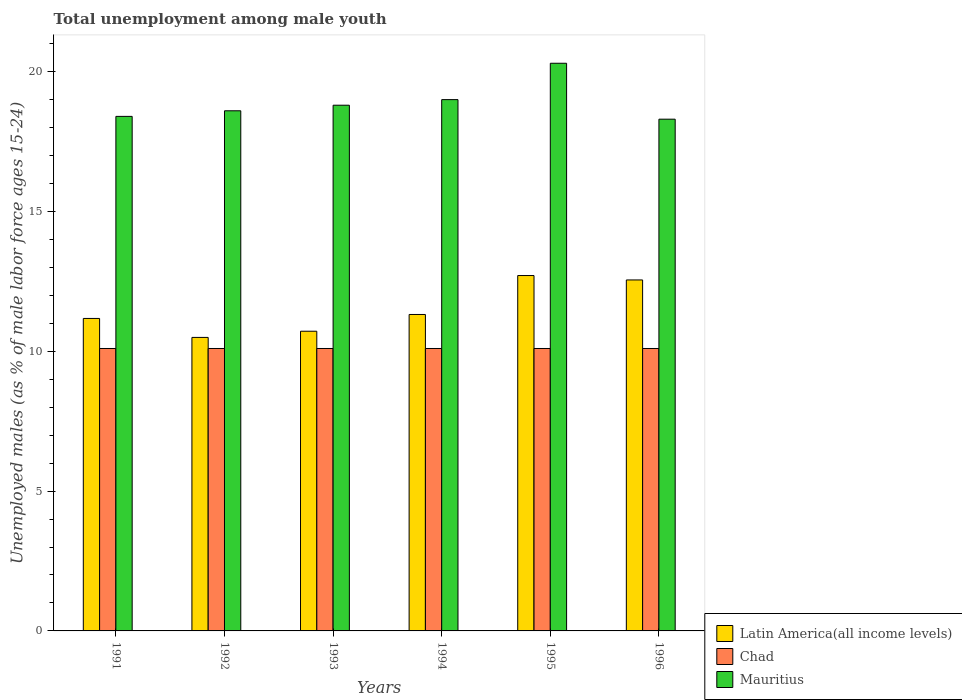Are the number of bars on each tick of the X-axis equal?
Offer a very short reply. Yes. How many bars are there on the 1st tick from the right?
Provide a succinct answer. 3. What is the label of the 5th group of bars from the left?
Ensure brevity in your answer.  1995. In how many cases, is the number of bars for a given year not equal to the number of legend labels?
Offer a terse response. 0. What is the percentage of unemployed males in in Chad in 1993?
Your answer should be very brief. 10.1. Across all years, what is the maximum percentage of unemployed males in in Latin America(all income levels)?
Keep it short and to the point. 12.71. Across all years, what is the minimum percentage of unemployed males in in Mauritius?
Your response must be concise. 18.3. In which year was the percentage of unemployed males in in Chad minimum?
Your answer should be very brief. 1991. What is the total percentage of unemployed males in in Latin America(all income levels) in the graph?
Offer a very short reply. 68.96. What is the difference between the percentage of unemployed males in in Mauritius in 1993 and that in 1995?
Ensure brevity in your answer.  -1.5. What is the difference between the percentage of unemployed males in in Mauritius in 1994 and the percentage of unemployed males in in Chad in 1995?
Provide a succinct answer. 8.9. What is the average percentage of unemployed males in in Mauritius per year?
Make the answer very short. 18.9. In the year 1995, what is the difference between the percentage of unemployed males in in Chad and percentage of unemployed males in in Latin America(all income levels)?
Offer a very short reply. -2.61. In how many years, is the percentage of unemployed males in in Mauritius greater than 18 %?
Your answer should be compact. 6. What is the ratio of the percentage of unemployed males in in Latin America(all income levels) in 1993 to that in 1994?
Keep it short and to the point. 0.95. Is the percentage of unemployed males in in Mauritius in 1993 less than that in 1995?
Keep it short and to the point. Yes. What is the difference between the highest and the second highest percentage of unemployed males in in Latin America(all income levels)?
Offer a terse response. 0.16. What is the difference between the highest and the lowest percentage of unemployed males in in Latin America(all income levels)?
Make the answer very short. 2.21. What does the 2nd bar from the left in 1992 represents?
Make the answer very short. Chad. What does the 1st bar from the right in 1994 represents?
Your answer should be compact. Mauritius. Is it the case that in every year, the sum of the percentage of unemployed males in in Latin America(all income levels) and percentage of unemployed males in in Mauritius is greater than the percentage of unemployed males in in Chad?
Your response must be concise. Yes. Are all the bars in the graph horizontal?
Keep it short and to the point. No. How many years are there in the graph?
Make the answer very short. 6. What is the difference between two consecutive major ticks on the Y-axis?
Make the answer very short. 5. Does the graph contain any zero values?
Your response must be concise. No. Does the graph contain grids?
Provide a short and direct response. No. Where does the legend appear in the graph?
Keep it short and to the point. Bottom right. What is the title of the graph?
Your response must be concise. Total unemployment among male youth. What is the label or title of the Y-axis?
Keep it short and to the point. Unemployed males (as % of male labor force ages 15-24). What is the Unemployed males (as % of male labor force ages 15-24) of Latin America(all income levels) in 1991?
Offer a terse response. 11.17. What is the Unemployed males (as % of male labor force ages 15-24) of Chad in 1991?
Keep it short and to the point. 10.1. What is the Unemployed males (as % of male labor force ages 15-24) of Mauritius in 1991?
Offer a very short reply. 18.4. What is the Unemployed males (as % of male labor force ages 15-24) in Latin America(all income levels) in 1992?
Provide a succinct answer. 10.5. What is the Unemployed males (as % of male labor force ages 15-24) of Chad in 1992?
Provide a short and direct response. 10.1. What is the Unemployed males (as % of male labor force ages 15-24) in Mauritius in 1992?
Provide a short and direct response. 18.6. What is the Unemployed males (as % of male labor force ages 15-24) in Latin America(all income levels) in 1993?
Your answer should be very brief. 10.72. What is the Unemployed males (as % of male labor force ages 15-24) in Chad in 1993?
Provide a succinct answer. 10.1. What is the Unemployed males (as % of male labor force ages 15-24) of Mauritius in 1993?
Offer a terse response. 18.8. What is the Unemployed males (as % of male labor force ages 15-24) in Latin America(all income levels) in 1994?
Ensure brevity in your answer.  11.32. What is the Unemployed males (as % of male labor force ages 15-24) in Chad in 1994?
Offer a terse response. 10.1. What is the Unemployed males (as % of male labor force ages 15-24) of Mauritius in 1994?
Ensure brevity in your answer.  19. What is the Unemployed males (as % of male labor force ages 15-24) in Latin America(all income levels) in 1995?
Ensure brevity in your answer.  12.71. What is the Unemployed males (as % of male labor force ages 15-24) in Chad in 1995?
Give a very brief answer. 10.1. What is the Unemployed males (as % of male labor force ages 15-24) of Mauritius in 1995?
Provide a short and direct response. 20.3. What is the Unemployed males (as % of male labor force ages 15-24) in Latin America(all income levels) in 1996?
Give a very brief answer. 12.55. What is the Unemployed males (as % of male labor force ages 15-24) in Chad in 1996?
Make the answer very short. 10.1. What is the Unemployed males (as % of male labor force ages 15-24) of Mauritius in 1996?
Provide a succinct answer. 18.3. Across all years, what is the maximum Unemployed males (as % of male labor force ages 15-24) in Latin America(all income levels)?
Offer a terse response. 12.71. Across all years, what is the maximum Unemployed males (as % of male labor force ages 15-24) in Chad?
Keep it short and to the point. 10.1. Across all years, what is the maximum Unemployed males (as % of male labor force ages 15-24) of Mauritius?
Make the answer very short. 20.3. Across all years, what is the minimum Unemployed males (as % of male labor force ages 15-24) in Latin America(all income levels)?
Your response must be concise. 10.5. Across all years, what is the minimum Unemployed males (as % of male labor force ages 15-24) in Chad?
Your answer should be compact. 10.1. Across all years, what is the minimum Unemployed males (as % of male labor force ages 15-24) of Mauritius?
Give a very brief answer. 18.3. What is the total Unemployed males (as % of male labor force ages 15-24) of Latin America(all income levels) in the graph?
Provide a short and direct response. 68.96. What is the total Unemployed males (as % of male labor force ages 15-24) in Chad in the graph?
Ensure brevity in your answer.  60.6. What is the total Unemployed males (as % of male labor force ages 15-24) in Mauritius in the graph?
Provide a succinct answer. 113.4. What is the difference between the Unemployed males (as % of male labor force ages 15-24) in Latin America(all income levels) in 1991 and that in 1992?
Make the answer very short. 0.68. What is the difference between the Unemployed males (as % of male labor force ages 15-24) of Latin America(all income levels) in 1991 and that in 1993?
Offer a very short reply. 0.46. What is the difference between the Unemployed males (as % of male labor force ages 15-24) in Mauritius in 1991 and that in 1993?
Your answer should be very brief. -0.4. What is the difference between the Unemployed males (as % of male labor force ages 15-24) of Latin America(all income levels) in 1991 and that in 1994?
Your response must be concise. -0.14. What is the difference between the Unemployed males (as % of male labor force ages 15-24) of Mauritius in 1991 and that in 1994?
Your answer should be very brief. -0.6. What is the difference between the Unemployed males (as % of male labor force ages 15-24) in Latin America(all income levels) in 1991 and that in 1995?
Ensure brevity in your answer.  -1.53. What is the difference between the Unemployed males (as % of male labor force ages 15-24) of Chad in 1991 and that in 1995?
Offer a very short reply. 0. What is the difference between the Unemployed males (as % of male labor force ages 15-24) of Latin America(all income levels) in 1991 and that in 1996?
Ensure brevity in your answer.  -1.38. What is the difference between the Unemployed males (as % of male labor force ages 15-24) of Chad in 1991 and that in 1996?
Your answer should be very brief. 0. What is the difference between the Unemployed males (as % of male labor force ages 15-24) of Mauritius in 1991 and that in 1996?
Your response must be concise. 0.1. What is the difference between the Unemployed males (as % of male labor force ages 15-24) of Latin America(all income levels) in 1992 and that in 1993?
Your answer should be very brief. -0.22. What is the difference between the Unemployed males (as % of male labor force ages 15-24) in Mauritius in 1992 and that in 1993?
Your answer should be very brief. -0.2. What is the difference between the Unemployed males (as % of male labor force ages 15-24) of Latin America(all income levels) in 1992 and that in 1994?
Provide a succinct answer. -0.82. What is the difference between the Unemployed males (as % of male labor force ages 15-24) in Latin America(all income levels) in 1992 and that in 1995?
Your answer should be very brief. -2.21. What is the difference between the Unemployed males (as % of male labor force ages 15-24) of Chad in 1992 and that in 1995?
Your answer should be very brief. 0. What is the difference between the Unemployed males (as % of male labor force ages 15-24) of Mauritius in 1992 and that in 1995?
Your response must be concise. -1.7. What is the difference between the Unemployed males (as % of male labor force ages 15-24) of Latin America(all income levels) in 1992 and that in 1996?
Provide a short and direct response. -2.06. What is the difference between the Unemployed males (as % of male labor force ages 15-24) of Mauritius in 1992 and that in 1996?
Your response must be concise. 0.3. What is the difference between the Unemployed males (as % of male labor force ages 15-24) of Latin America(all income levels) in 1993 and that in 1994?
Offer a terse response. -0.6. What is the difference between the Unemployed males (as % of male labor force ages 15-24) in Chad in 1993 and that in 1994?
Your answer should be very brief. 0. What is the difference between the Unemployed males (as % of male labor force ages 15-24) of Mauritius in 1993 and that in 1994?
Your response must be concise. -0.2. What is the difference between the Unemployed males (as % of male labor force ages 15-24) of Latin America(all income levels) in 1993 and that in 1995?
Provide a succinct answer. -1.99. What is the difference between the Unemployed males (as % of male labor force ages 15-24) of Latin America(all income levels) in 1993 and that in 1996?
Your answer should be very brief. -1.83. What is the difference between the Unemployed males (as % of male labor force ages 15-24) of Chad in 1993 and that in 1996?
Your response must be concise. 0. What is the difference between the Unemployed males (as % of male labor force ages 15-24) of Mauritius in 1993 and that in 1996?
Provide a succinct answer. 0.5. What is the difference between the Unemployed males (as % of male labor force ages 15-24) of Latin America(all income levels) in 1994 and that in 1995?
Your answer should be compact. -1.39. What is the difference between the Unemployed males (as % of male labor force ages 15-24) of Latin America(all income levels) in 1994 and that in 1996?
Give a very brief answer. -1.24. What is the difference between the Unemployed males (as % of male labor force ages 15-24) in Latin America(all income levels) in 1995 and that in 1996?
Provide a short and direct response. 0.16. What is the difference between the Unemployed males (as % of male labor force ages 15-24) in Latin America(all income levels) in 1991 and the Unemployed males (as % of male labor force ages 15-24) in Chad in 1992?
Provide a short and direct response. 1.07. What is the difference between the Unemployed males (as % of male labor force ages 15-24) in Latin America(all income levels) in 1991 and the Unemployed males (as % of male labor force ages 15-24) in Mauritius in 1992?
Ensure brevity in your answer.  -7.43. What is the difference between the Unemployed males (as % of male labor force ages 15-24) of Chad in 1991 and the Unemployed males (as % of male labor force ages 15-24) of Mauritius in 1992?
Provide a succinct answer. -8.5. What is the difference between the Unemployed males (as % of male labor force ages 15-24) in Latin America(all income levels) in 1991 and the Unemployed males (as % of male labor force ages 15-24) in Chad in 1993?
Provide a short and direct response. 1.07. What is the difference between the Unemployed males (as % of male labor force ages 15-24) of Latin America(all income levels) in 1991 and the Unemployed males (as % of male labor force ages 15-24) of Mauritius in 1993?
Offer a very short reply. -7.63. What is the difference between the Unemployed males (as % of male labor force ages 15-24) of Latin America(all income levels) in 1991 and the Unemployed males (as % of male labor force ages 15-24) of Chad in 1994?
Give a very brief answer. 1.07. What is the difference between the Unemployed males (as % of male labor force ages 15-24) in Latin America(all income levels) in 1991 and the Unemployed males (as % of male labor force ages 15-24) in Mauritius in 1994?
Keep it short and to the point. -7.83. What is the difference between the Unemployed males (as % of male labor force ages 15-24) of Latin America(all income levels) in 1991 and the Unemployed males (as % of male labor force ages 15-24) of Chad in 1995?
Provide a succinct answer. 1.07. What is the difference between the Unemployed males (as % of male labor force ages 15-24) in Latin America(all income levels) in 1991 and the Unemployed males (as % of male labor force ages 15-24) in Mauritius in 1995?
Make the answer very short. -9.13. What is the difference between the Unemployed males (as % of male labor force ages 15-24) of Chad in 1991 and the Unemployed males (as % of male labor force ages 15-24) of Mauritius in 1995?
Offer a terse response. -10.2. What is the difference between the Unemployed males (as % of male labor force ages 15-24) in Latin America(all income levels) in 1991 and the Unemployed males (as % of male labor force ages 15-24) in Chad in 1996?
Offer a terse response. 1.07. What is the difference between the Unemployed males (as % of male labor force ages 15-24) of Latin America(all income levels) in 1991 and the Unemployed males (as % of male labor force ages 15-24) of Mauritius in 1996?
Give a very brief answer. -7.13. What is the difference between the Unemployed males (as % of male labor force ages 15-24) in Chad in 1991 and the Unemployed males (as % of male labor force ages 15-24) in Mauritius in 1996?
Your answer should be compact. -8.2. What is the difference between the Unemployed males (as % of male labor force ages 15-24) of Latin America(all income levels) in 1992 and the Unemployed males (as % of male labor force ages 15-24) of Chad in 1993?
Your answer should be very brief. 0.4. What is the difference between the Unemployed males (as % of male labor force ages 15-24) of Latin America(all income levels) in 1992 and the Unemployed males (as % of male labor force ages 15-24) of Mauritius in 1993?
Your answer should be compact. -8.3. What is the difference between the Unemployed males (as % of male labor force ages 15-24) of Latin America(all income levels) in 1992 and the Unemployed males (as % of male labor force ages 15-24) of Chad in 1994?
Your answer should be compact. 0.4. What is the difference between the Unemployed males (as % of male labor force ages 15-24) in Latin America(all income levels) in 1992 and the Unemployed males (as % of male labor force ages 15-24) in Mauritius in 1994?
Ensure brevity in your answer.  -8.5. What is the difference between the Unemployed males (as % of male labor force ages 15-24) in Latin America(all income levels) in 1992 and the Unemployed males (as % of male labor force ages 15-24) in Chad in 1995?
Offer a terse response. 0.4. What is the difference between the Unemployed males (as % of male labor force ages 15-24) in Latin America(all income levels) in 1992 and the Unemployed males (as % of male labor force ages 15-24) in Mauritius in 1995?
Your response must be concise. -9.8. What is the difference between the Unemployed males (as % of male labor force ages 15-24) in Latin America(all income levels) in 1992 and the Unemployed males (as % of male labor force ages 15-24) in Chad in 1996?
Your answer should be compact. 0.4. What is the difference between the Unemployed males (as % of male labor force ages 15-24) of Latin America(all income levels) in 1992 and the Unemployed males (as % of male labor force ages 15-24) of Mauritius in 1996?
Your response must be concise. -7.8. What is the difference between the Unemployed males (as % of male labor force ages 15-24) of Chad in 1992 and the Unemployed males (as % of male labor force ages 15-24) of Mauritius in 1996?
Keep it short and to the point. -8.2. What is the difference between the Unemployed males (as % of male labor force ages 15-24) in Latin America(all income levels) in 1993 and the Unemployed males (as % of male labor force ages 15-24) in Chad in 1994?
Your answer should be compact. 0.62. What is the difference between the Unemployed males (as % of male labor force ages 15-24) in Latin America(all income levels) in 1993 and the Unemployed males (as % of male labor force ages 15-24) in Mauritius in 1994?
Make the answer very short. -8.28. What is the difference between the Unemployed males (as % of male labor force ages 15-24) in Chad in 1993 and the Unemployed males (as % of male labor force ages 15-24) in Mauritius in 1994?
Ensure brevity in your answer.  -8.9. What is the difference between the Unemployed males (as % of male labor force ages 15-24) in Latin America(all income levels) in 1993 and the Unemployed males (as % of male labor force ages 15-24) in Chad in 1995?
Your answer should be very brief. 0.62. What is the difference between the Unemployed males (as % of male labor force ages 15-24) of Latin America(all income levels) in 1993 and the Unemployed males (as % of male labor force ages 15-24) of Mauritius in 1995?
Your answer should be very brief. -9.58. What is the difference between the Unemployed males (as % of male labor force ages 15-24) in Chad in 1993 and the Unemployed males (as % of male labor force ages 15-24) in Mauritius in 1995?
Provide a short and direct response. -10.2. What is the difference between the Unemployed males (as % of male labor force ages 15-24) in Latin America(all income levels) in 1993 and the Unemployed males (as % of male labor force ages 15-24) in Chad in 1996?
Offer a very short reply. 0.62. What is the difference between the Unemployed males (as % of male labor force ages 15-24) of Latin America(all income levels) in 1993 and the Unemployed males (as % of male labor force ages 15-24) of Mauritius in 1996?
Your response must be concise. -7.58. What is the difference between the Unemployed males (as % of male labor force ages 15-24) of Chad in 1993 and the Unemployed males (as % of male labor force ages 15-24) of Mauritius in 1996?
Offer a terse response. -8.2. What is the difference between the Unemployed males (as % of male labor force ages 15-24) of Latin America(all income levels) in 1994 and the Unemployed males (as % of male labor force ages 15-24) of Chad in 1995?
Offer a terse response. 1.22. What is the difference between the Unemployed males (as % of male labor force ages 15-24) of Latin America(all income levels) in 1994 and the Unemployed males (as % of male labor force ages 15-24) of Mauritius in 1995?
Offer a very short reply. -8.98. What is the difference between the Unemployed males (as % of male labor force ages 15-24) of Chad in 1994 and the Unemployed males (as % of male labor force ages 15-24) of Mauritius in 1995?
Provide a short and direct response. -10.2. What is the difference between the Unemployed males (as % of male labor force ages 15-24) in Latin America(all income levels) in 1994 and the Unemployed males (as % of male labor force ages 15-24) in Chad in 1996?
Keep it short and to the point. 1.22. What is the difference between the Unemployed males (as % of male labor force ages 15-24) of Latin America(all income levels) in 1994 and the Unemployed males (as % of male labor force ages 15-24) of Mauritius in 1996?
Keep it short and to the point. -6.98. What is the difference between the Unemployed males (as % of male labor force ages 15-24) of Chad in 1994 and the Unemployed males (as % of male labor force ages 15-24) of Mauritius in 1996?
Provide a short and direct response. -8.2. What is the difference between the Unemployed males (as % of male labor force ages 15-24) in Latin America(all income levels) in 1995 and the Unemployed males (as % of male labor force ages 15-24) in Chad in 1996?
Offer a very short reply. 2.61. What is the difference between the Unemployed males (as % of male labor force ages 15-24) in Latin America(all income levels) in 1995 and the Unemployed males (as % of male labor force ages 15-24) in Mauritius in 1996?
Make the answer very short. -5.59. What is the average Unemployed males (as % of male labor force ages 15-24) of Latin America(all income levels) per year?
Your answer should be very brief. 11.49. What is the average Unemployed males (as % of male labor force ages 15-24) in Mauritius per year?
Keep it short and to the point. 18.9. In the year 1991, what is the difference between the Unemployed males (as % of male labor force ages 15-24) of Latin America(all income levels) and Unemployed males (as % of male labor force ages 15-24) of Chad?
Your response must be concise. 1.07. In the year 1991, what is the difference between the Unemployed males (as % of male labor force ages 15-24) of Latin America(all income levels) and Unemployed males (as % of male labor force ages 15-24) of Mauritius?
Your answer should be compact. -7.23. In the year 1992, what is the difference between the Unemployed males (as % of male labor force ages 15-24) in Latin America(all income levels) and Unemployed males (as % of male labor force ages 15-24) in Chad?
Offer a very short reply. 0.4. In the year 1992, what is the difference between the Unemployed males (as % of male labor force ages 15-24) of Latin America(all income levels) and Unemployed males (as % of male labor force ages 15-24) of Mauritius?
Ensure brevity in your answer.  -8.1. In the year 1992, what is the difference between the Unemployed males (as % of male labor force ages 15-24) of Chad and Unemployed males (as % of male labor force ages 15-24) of Mauritius?
Make the answer very short. -8.5. In the year 1993, what is the difference between the Unemployed males (as % of male labor force ages 15-24) of Latin America(all income levels) and Unemployed males (as % of male labor force ages 15-24) of Chad?
Your response must be concise. 0.62. In the year 1993, what is the difference between the Unemployed males (as % of male labor force ages 15-24) in Latin America(all income levels) and Unemployed males (as % of male labor force ages 15-24) in Mauritius?
Offer a very short reply. -8.08. In the year 1994, what is the difference between the Unemployed males (as % of male labor force ages 15-24) of Latin America(all income levels) and Unemployed males (as % of male labor force ages 15-24) of Chad?
Give a very brief answer. 1.22. In the year 1994, what is the difference between the Unemployed males (as % of male labor force ages 15-24) of Latin America(all income levels) and Unemployed males (as % of male labor force ages 15-24) of Mauritius?
Provide a short and direct response. -7.68. In the year 1994, what is the difference between the Unemployed males (as % of male labor force ages 15-24) in Chad and Unemployed males (as % of male labor force ages 15-24) in Mauritius?
Your response must be concise. -8.9. In the year 1995, what is the difference between the Unemployed males (as % of male labor force ages 15-24) in Latin America(all income levels) and Unemployed males (as % of male labor force ages 15-24) in Chad?
Provide a short and direct response. 2.61. In the year 1995, what is the difference between the Unemployed males (as % of male labor force ages 15-24) in Latin America(all income levels) and Unemployed males (as % of male labor force ages 15-24) in Mauritius?
Keep it short and to the point. -7.59. In the year 1995, what is the difference between the Unemployed males (as % of male labor force ages 15-24) of Chad and Unemployed males (as % of male labor force ages 15-24) of Mauritius?
Your answer should be very brief. -10.2. In the year 1996, what is the difference between the Unemployed males (as % of male labor force ages 15-24) in Latin America(all income levels) and Unemployed males (as % of male labor force ages 15-24) in Chad?
Provide a short and direct response. 2.45. In the year 1996, what is the difference between the Unemployed males (as % of male labor force ages 15-24) in Latin America(all income levels) and Unemployed males (as % of male labor force ages 15-24) in Mauritius?
Provide a short and direct response. -5.75. What is the ratio of the Unemployed males (as % of male labor force ages 15-24) in Latin America(all income levels) in 1991 to that in 1992?
Your answer should be very brief. 1.06. What is the ratio of the Unemployed males (as % of male labor force ages 15-24) of Mauritius in 1991 to that in 1992?
Your response must be concise. 0.99. What is the ratio of the Unemployed males (as % of male labor force ages 15-24) of Latin America(all income levels) in 1991 to that in 1993?
Offer a very short reply. 1.04. What is the ratio of the Unemployed males (as % of male labor force ages 15-24) of Mauritius in 1991 to that in 1993?
Keep it short and to the point. 0.98. What is the ratio of the Unemployed males (as % of male labor force ages 15-24) in Latin America(all income levels) in 1991 to that in 1994?
Your answer should be compact. 0.99. What is the ratio of the Unemployed males (as % of male labor force ages 15-24) of Mauritius in 1991 to that in 1994?
Offer a very short reply. 0.97. What is the ratio of the Unemployed males (as % of male labor force ages 15-24) of Latin America(all income levels) in 1991 to that in 1995?
Your response must be concise. 0.88. What is the ratio of the Unemployed males (as % of male labor force ages 15-24) in Mauritius in 1991 to that in 1995?
Ensure brevity in your answer.  0.91. What is the ratio of the Unemployed males (as % of male labor force ages 15-24) of Latin America(all income levels) in 1991 to that in 1996?
Provide a short and direct response. 0.89. What is the ratio of the Unemployed males (as % of male labor force ages 15-24) of Mauritius in 1991 to that in 1996?
Offer a terse response. 1.01. What is the ratio of the Unemployed males (as % of male labor force ages 15-24) in Latin America(all income levels) in 1992 to that in 1993?
Ensure brevity in your answer.  0.98. What is the ratio of the Unemployed males (as % of male labor force ages 15-24) in Mauritius in 1992 to that in 1993?
Offer a very short reply. 0.99. What is the ratio of the Unemployed males (as % of male labor force ages 15-24) of Latin America(all income levels) in 1992 to that in 1994?
Provide a short and direct response. 0.93. What is the ratio of the Unemployed males (as % of male labor force ages 15-24) of Mauritius in 1992 to that in 1994?
Ensure brevity in your answer.  0.98. What is the ratio of the Unemployed males (as % of male labor force ages 15-24) of Latin America(all income levels) in 1992 to that in 1995?
Your answer should be compact. 0.83. What is the ratio of the Unemployed males (as % of male labor force ages 15-24) of Mauritius in 1992 to that in 1995?
Ensure brevity in your answer.  0.92. What is the ratio of the Unemployed males (as % of male labor force ages 15-24) in Latin America(all income levels) in 1992 to that in 1996?
Offer a terse response. 0.84. What is the ratio of the Unemployed males (as % of male labor force ages 15-24) in Chad in 1992 to that in 1996?
Keep it short and to the point. 1. What is the ratio of the Unemployed males (as % of male labor force ages 15-24) in Mauritius in 1992 to that in 1996?
Your response must be concise. 1.02. What is the ratio of the Unemployed males (as % of male labor force ages 15-24) in Latin America(all income levels) in 1993 to that in 1994?
Ensure brevity in your answer.  0.95. What is the ratio of the Unemployed males (as % of male labor force ages 15-24) of Latin America(all income levels) in 1993 to that in 1995?
Your answer should be very brief. 0.84. What is the ratio of the Unemployed males (as % of male labor force ages 15-24) in Chad in 1993 to that in 1995?
Offer a very short reply. 1. What is the ratio of the Unemployed males (as % of male labor force ages 15-24) in Mauritius in 1993 to that in 1995?
Your response must be concise. 0.93. What is the ratio of the Unemployed males (as % of male labor force ages 15-24) in Latin America(all income levels) in 1993 to that in 1996?
Keep it short and to the point. 0.85. What is the ratio of the Unemployed males (as % of male labor force ages 15-24) of Chad in 1993 to that in 1996?
Your answer should be very brief. 1. What is the ratio of the Unemployed males (as % of male labor force ages 15-24) of Mauritius in 1993 to that in 1996?
Provide a short and direct response. 1.03. What is the ratio of the Unemployed males (as % of male labor force ages 15-24) in Latin America(all income levels) in 1994 to that in 1995?
Keep it short and to the point. 0.89. What is the ratio of the Unemployed males (as % of male labor force ages 15-24) in Mauritius in 1994 to that in 1995?
Provide a succinct answer. 0.94. What is the ratio of the Unemployed males (as % of male labor force ages 15-24) in Latin America(all income levels) in 1994 to that in 1996?
Give a very brief answer. 0.9. What is the ratio of the Unemployed males (as % of male labor force ages 15-24) in Mauritius in 1994 to that in 1996?
Your answer should be very brief. 1.04. What is the ratio of the Unemployed males (as % of male labor force ages 15-24) of Latin America(all income levels) in 1995 to that in 1996?
Provide a succinct answer. 1.01. What is the ratio of the Unemployed males (as % of male labor force ages 15-24) in Chad in 1995 to that in 1996?
Offer a very short reply. 1. What is the ratio of the Unemployed males (as % of male labor force ages 15-24) of Mauritius in 1995 to that in 1996?
Your answer should be very brief. 1.11. What is the difference between the highest and the second highest Unemployed males (as % of male labor force ages 15-24) in Latin America(all income levels)?
Provide a short and direct response. 0.16. What is the difference between the highest and the second highest Unemployed males (as % of male labor force ages 15-24) of Chad?
Provide a short and direct response. 0. What is the difference between the highest and the second highest Unemployed males (as % of male labor force ages 15-24) of Mauritius?
Offer a very short reply. 1.3. What is the difference between the highest and the lowest Unemployed males (as % of male labor force ages 15-24) in Latin America(all income levels)?
Make the answer very short. 2.21. What is the difference between the highest and the lowest Unemployed males (as % of male labor force ages 15-24) of Mauritius?
Your answer should be very brief. 2. 